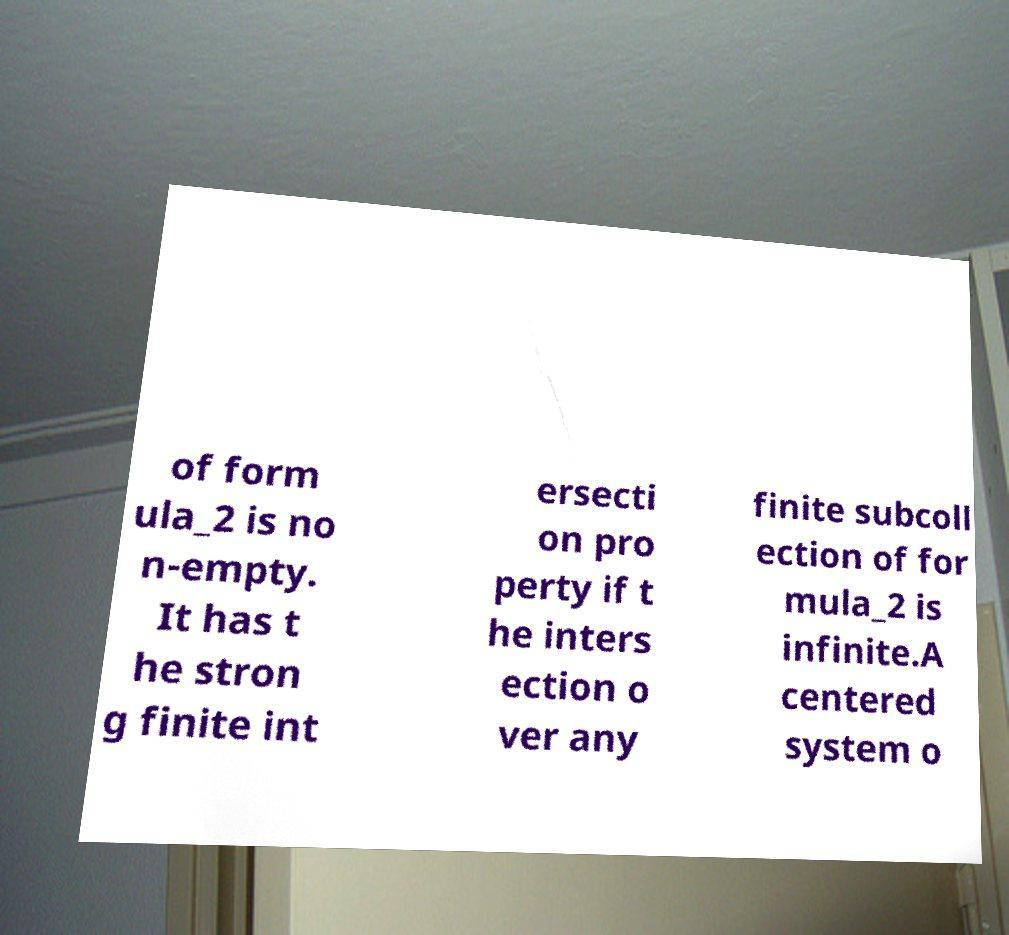There's text embedded in this image that I need extracted. Can you transcribe it verbatim? of form ula_2 is no n-empty. It has t he stron g finite int ersecti on pro perty if t he inters ection o ver any finite subcoll ection of for mula_2 is infinite.A centered system o 